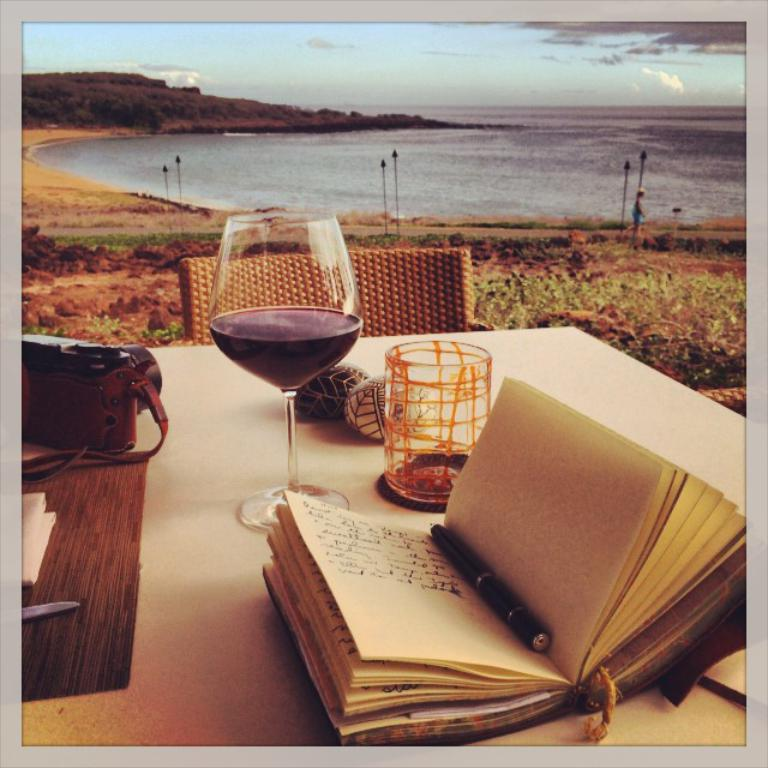What is the main piece of furniture in the image? There is a table in the image. What is placed on the table? There is a book and a wine glass on the table. What is in front of the table? There is a chair in front of the table. What can be seen in the background of the image? The background of the image is a beach. What is visible at the top of the image? The sky is visible at the top of the image and is filled with clouds. How many children can be seen playing on the beach in the image? There are no children visible in the image; it only shows a table with a book and a wine glass, a chair, and a beach background. 